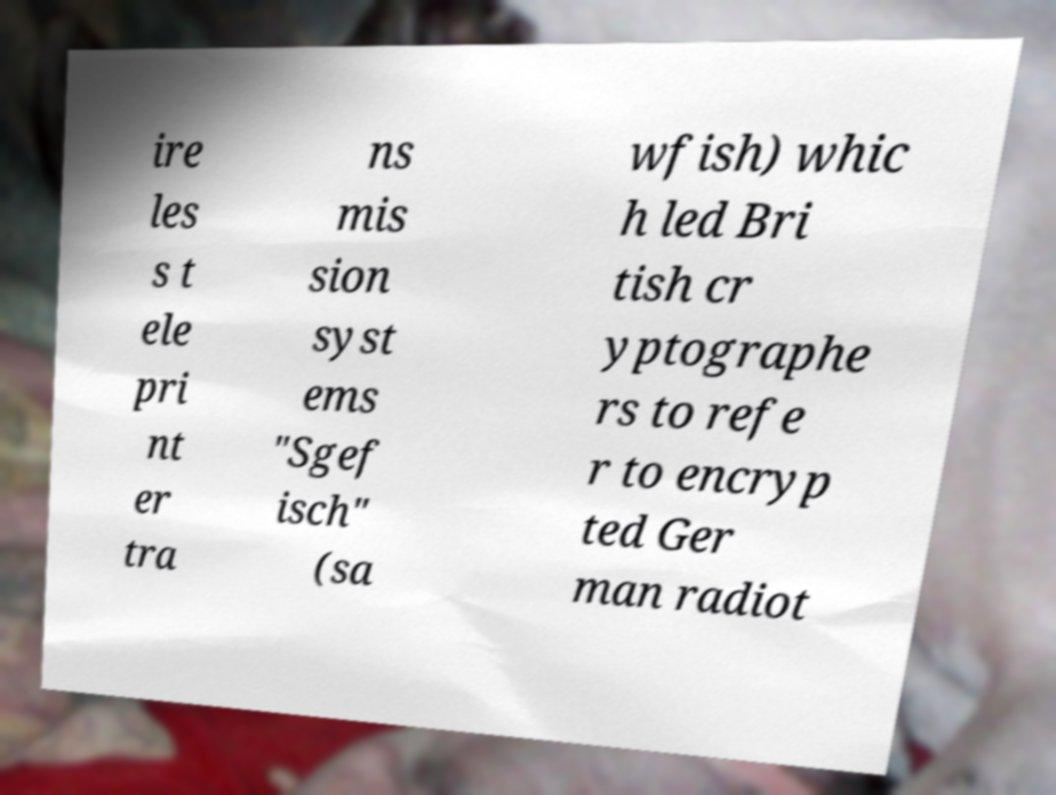Could you extract and type out the text from this image? ire les s t ele pri nt er tra ns mis sion syst ems "Sgef isch" (sa wfish) whic h led Bri tish cr yptographe rs to refe r to encryp ted Ger man radiot 